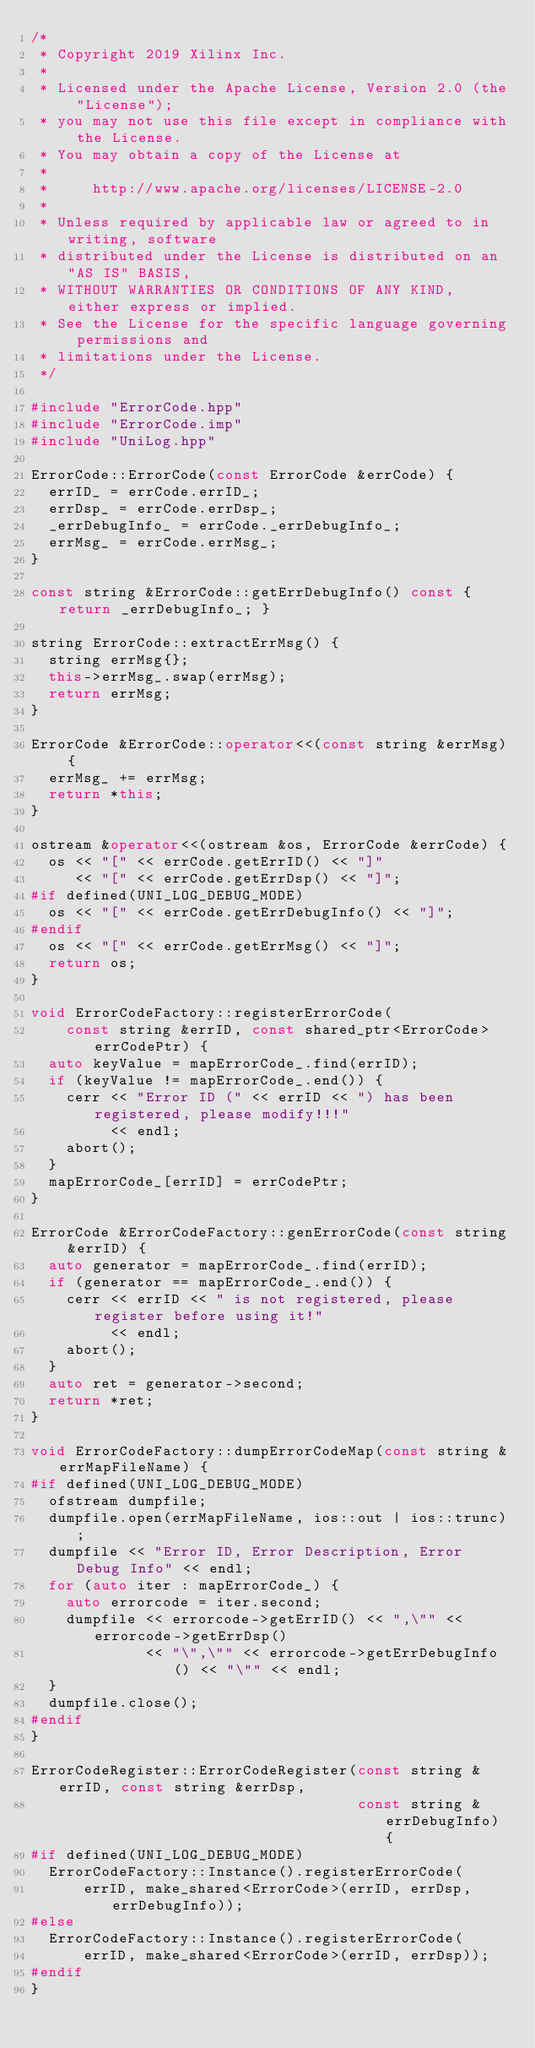<code> <loc_0><loc_0><loc_500><loc_500><_C++_>/*
 * Copyright 2019 Xilinx Inc.
 *
 * Licensed under the Apache License, Version 2.0 (the "License");
 * you may not use this file except in compliance with the License.
 * You may obtain a copy of the License at
 *
 *     http://www.apache.org/licenses/LICENSE-2.0
 *
 * Unless required by applicable law or agreed to in writing, software
 * distributed under the License is distributed on an "AS IS" BASIS,
 * WITHOUT WARRANTIES OR CONDITIONS OF ANY KIND, either express or implied.
 * See the License for the specific language governing permissions and
 * limitations under the License.
 */

#include "ErrorCode.hpp"
#include "ErrorCode.imp"
#include "UniLog.hpp"

ErrorCode::ErrorCode(const ErrorCode &errCode) {
  errID_ = errCode.errID_;
  errDsp_ = errCode.errDsp_;
  _errDebugInfo_ = errCode._errDebugInfo_;
  errMsg_ = errCode.errMsg_;
}

const string &ErrorCode::getErrDebugInfo() const { return _errDebugInfo_; }

string ErrorCode::extractErrMsg() {
  string errMsg{};
  this->errMsg_.swap(errMsg);
  return errMsg;
}

ErrorCode &ErrorCode::operator<<(const string &errMsg) {
  errMsg_ += errMsg;
  return *this;
}

ostream &operator<<(ostream &os, ErrorCode &errCode) {
  os << "[" << errCode.getErrID() << "]"
     << "[" << errCode.getErrDsp() << "]";
#if defined(UNI_LOG_DEBUG_MODE)
  os << "[" << errCode.getErrDebugInfo() << "]";
#endif
  os << "[" << errCode.getErrMsg() << "]";
  return os;
}

void ErrorCodeFactory::registerErrorCode(
    const string &errID, const shared_ptr<ErrorCode> errCodePtr) {
  auto keyValue = mapErrorCode_.find(errID);
  if (keyValue != mapErrorCode_.end()) {
    cerr << "Error ID (" << errID << ") has been registered, please modify!!!"
         << endl;
    abort();
  }
  mapErrorCode_[errID] = errCodePtr;
}

ErrorCode &ErrorCodeFactory::genErrorCode(const string &errID) {
  auto generator = mapErrorCode_.find(errID);
  if (generator == mapErrorCode_.end()) {
    cerr << errID << " is not registered, please register before using it!"
         << endl;
    abort();
  }
  auto ret = generator->second;
  return *ret;
}

void ErrorCodeFactory::dumpErrorCodeMap(const string &errMapFileName) {
#if defined(UNI_LOG_DEBUG_MODE)
  ofstream dumpfile;
  dumpfile.open(errMapFileName, ios::out | ios::trunc);
  dumpfile << "Error ID, Error Description, Error Debug Info" << endl;
  for (auto iter : mapErrorCode_) {
    auto errorcode = iter.second;
    dumpfile << errorcode->getErrID() << ",\"" << errorcode->getErrDsp()
             << "\",\"" << errorcode->getErrDebugInfo() << "\"" << endl;
  }
  dumpfile.close();
#endif
}

ErrorCodeRegister::ErrorCodeRegister(const string &errID, const string &errDsp,
                                     const string &errDebugInfo) {
#if defined(UNI_LOG_DEBUG_MODE)
  ErrorCodeFactory::Instance().registerErrorCode(
      errID, make_shared<ErrorCode>(errID, errDsp, errDebugInfo));
#else
  ErrorCodeFactory::Instance().registerErrorCode(
      errID, make_shared<ErrorCode>(errID, errDsp));
#endif
}
</code> 